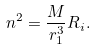Convert formula to latex. <formula><loc_0><loc_0><loc_500><loc_500>n ^ { 2 } = \frac { M } { r _ { 1 } ^ { 3 } } R _ { i } .</formula> 